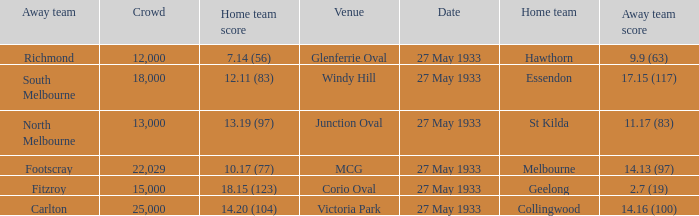Parse the full table. {'header': ['Away team', 'Crowd', 'Home team score', 'Venue', 'Date', 'Home team', 'Away team score'], 'rows': [['Richmond', '12,000', '7.14 (56)', 'Glenferrie Oval', '27 May 1933', 'Hawthorn', '9.9 (63)'], ['South Melbourne', '18,000', '12.11 (83)', 'Windy Hill', '27 May 1933', 'Essendon', '17.15 (117)'], ['North Melbourne', '13,000', '13.19 (97)', 'Junction Oval', '27 May 1933', 'St Kilda', '11.17 (83)'], ['Footscray', '22,029', '10.17 (77)', 'MCG', '27 May 1933', 'Melbourne', '14.13 (97)'], ['Fitzroy', '15,000', '18.15 (123)', 'Corio Oval', '27 May 1933', 'Geelong', '2.7 (19)'], ['Carlton', '25,000', '14.20 (104)', 'Victoria Park', '27 May 1933', 'Collingwood', '14.16 (100)']]} In the match where the away team scored 2.7 (19), how many peopel were in the crowd? 15000.0. 